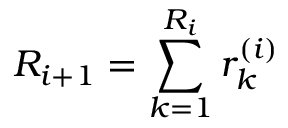Convert formula to latex. <formula><loc_0><loc_0><loc_500><loc_500>R _ { i + 1 } = \sum _ { k = 1 } ^ { R _ { i } } r _ { k } ^ { ( i ) }</formula> 